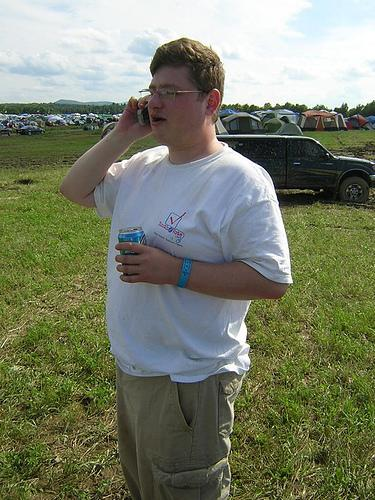Where will people located here sleep tonight? tents 